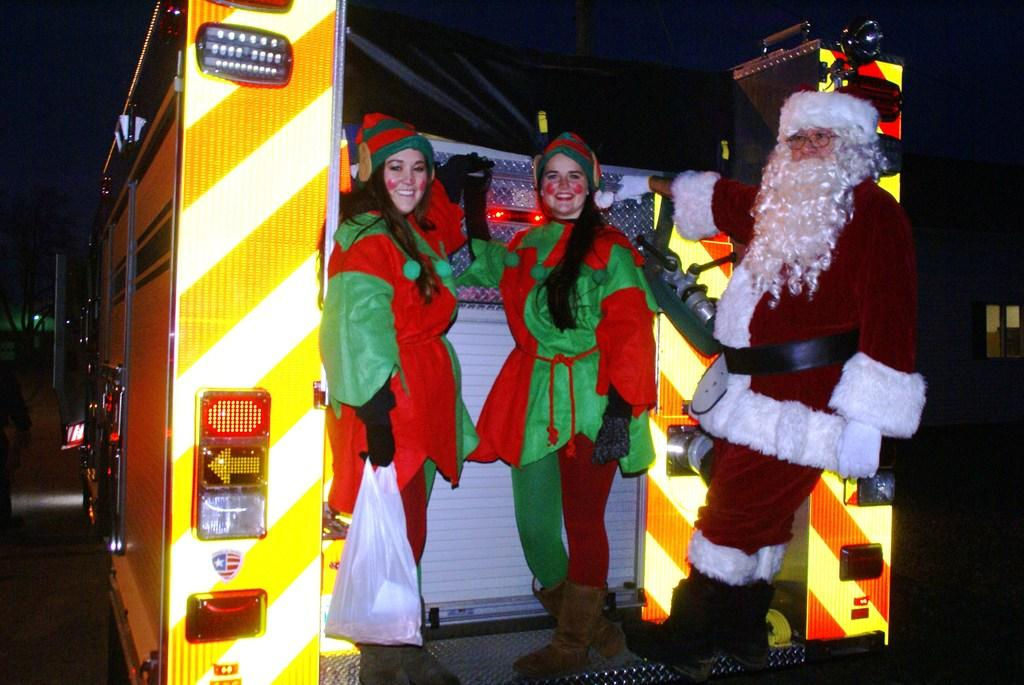How many women are in the image? There are two women in the image. What are the women doing in the image? The women are smiling. What is one of the women holding in the image? One of the women is holding a plastic cover. What additional character is present in the image? There is a Santa Claus in the image. What type of object is visible in the image? The image contains a vehicle. How would you describe the lighting in the image? The background of the image is dark. What type of trail can be seen in the image? There is no trail present in the image. How does the Santa Claus react to the women in the image? The image does not show the Santa Claus reacting to the women, as it only depicts the characters and objects mentioned in the facts. 